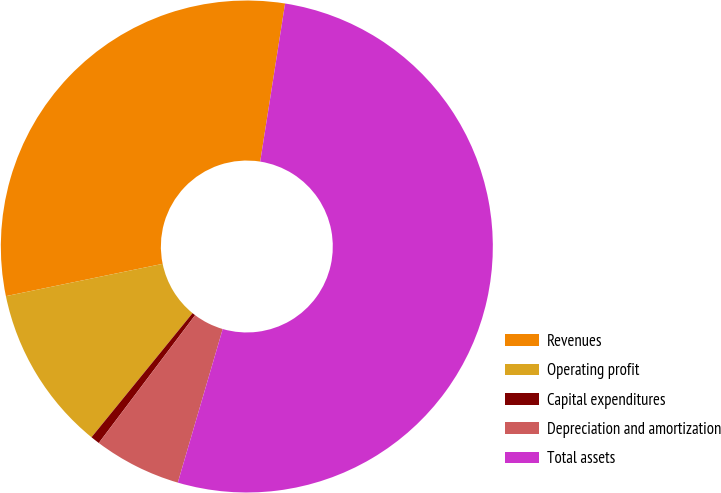Convert chart to OTSL. <chart><loc_0><loc_0><loc_500><loc_500><pie_chart><fcel>Revenues<fcel>Operating profit<fcel>Capital expenditures<fcel>Depreciation and amortization<fcel>Total assets<nl><fcel>30.72%<fcel>10.89%<fcel>0.6%<fcel>5.75%<fcel>52.04%<nl></chart> 